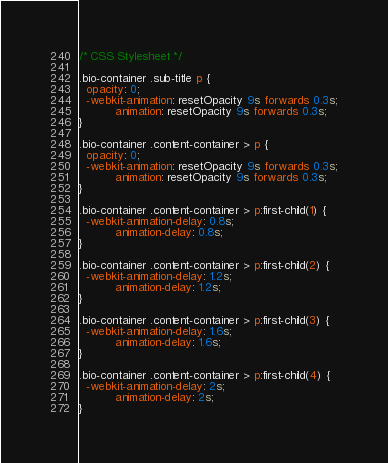Convert code to text. <code><loc_0><loc_0><loc_500><loc_500><_CSS_>/* CSS Stylesheet */

.bio-container .sub-title p {
  opacity: 0;
  -webkit-animation: resetOpacity 9s forwards 0.3s;
          animation: resetOpacity 9s forwards 0.3s;
}

.bio-container .content-container > p {
  opacity: 0;
  -webkit-animation: resetOpacity 9s forwards 0.3s;
          animation: resetOpacity 9s forwards 0.3s;
}

.bio-container .content-container > p:first-child(1) {
  -webkit-animation-delay: 0.8s;
          animation-delay: 0.8s;
}

.bio-container .content-container > p:first-child(2) {
  -webkit-animation-delay: 1.2s;
          animation-delay: 1.2s;
}

.bio-container .content-container > p:first-child(3) {
  -webkit-animation-delay: 1.6s;
          animation-delay: 1.6s;
}

.bio-container .content-container > p:first-child(4) {
  -webkit-animation-delay: 2s;
          animation-delay: 2s;
}
</code> 